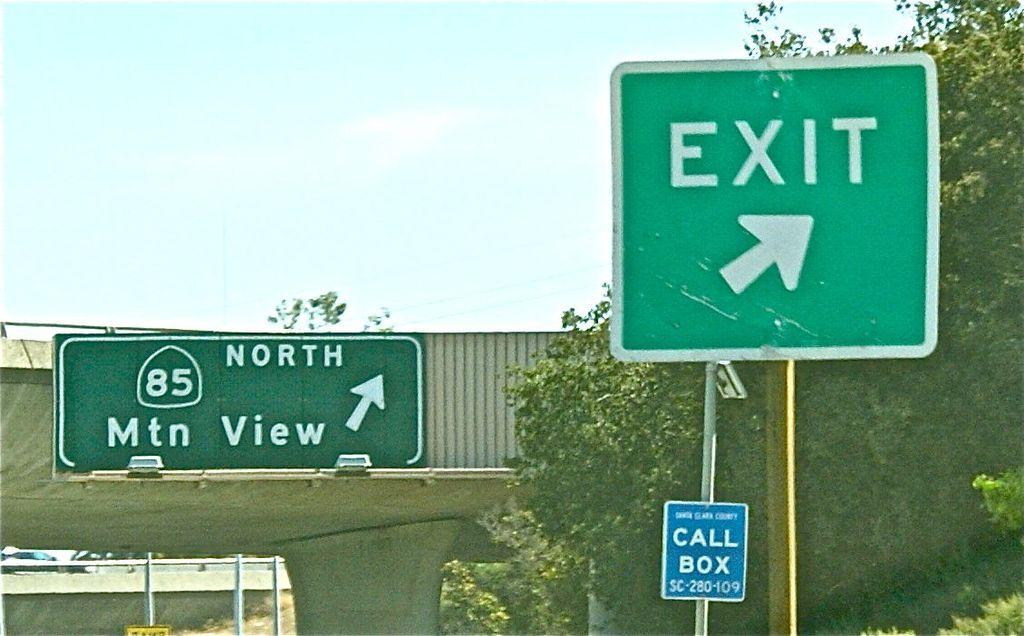<image>
Create a compact narrative representing the image presented. highway signs like 85 North to Mtn View and Call Box 